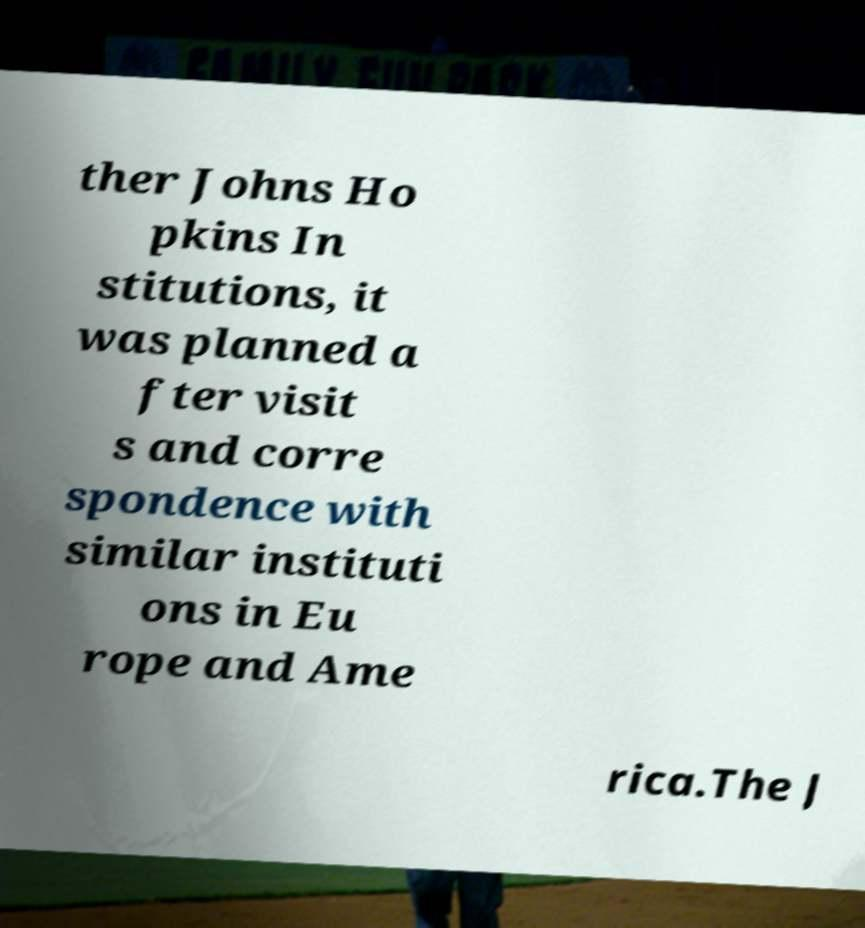What messages or text are displayed in this image? I need them in a readable, typed format. ther Johns Ho pkins In stitutions, it was planned a fter visit s and corre spondence with similar instituti ons in Eu rope and Ame rica.The J 